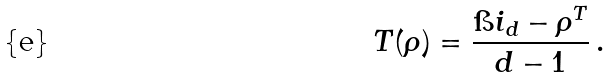Convert formula to latex. <formula><loc_0><loc_0><loc_500><loc_500>T ( \rho ) = \frac { \i i _ { d } - \rho ^ { T } } { d - 1 } \, .</formula> 